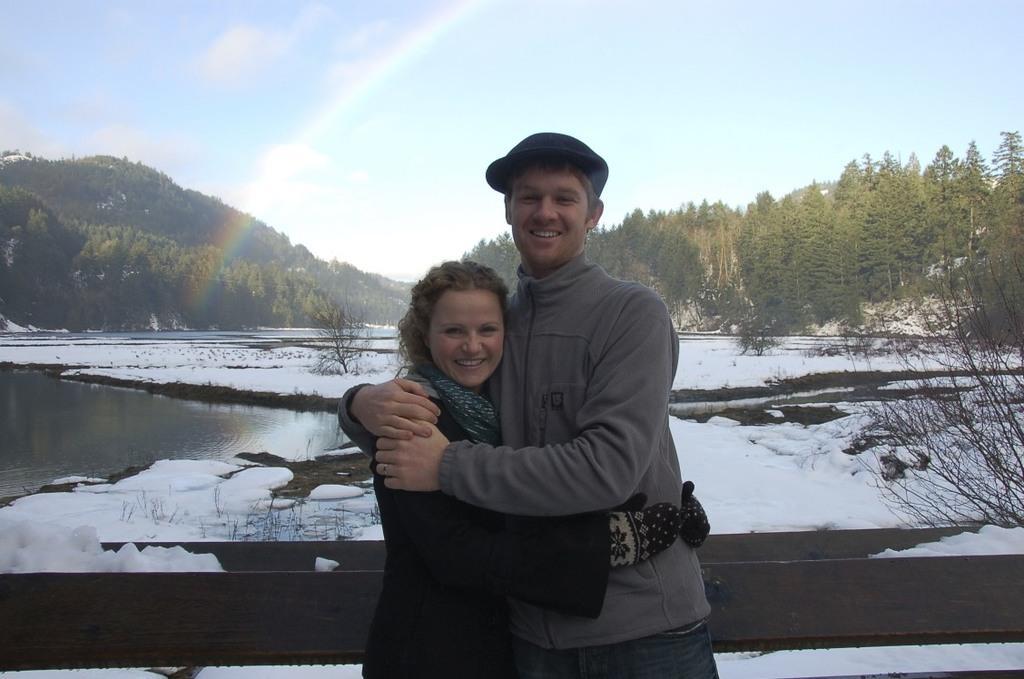Could you give a brief overview of what you see in this image? In this image we can see two people standing. One person is wearing a cap. In the background, we can see a wooden fence, water, a group of trees, a rainbow and the cloudy sky. 